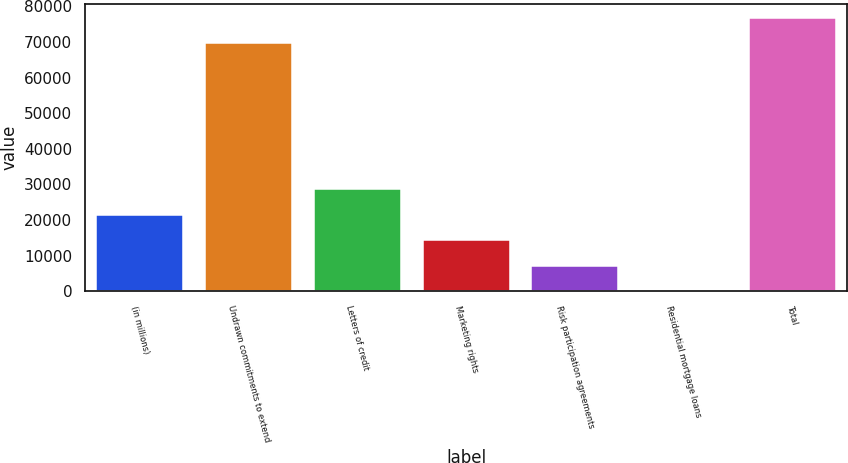<chart> <loc_0><loc_0><loc_500><loc_500><bar_chart><fcel>(in millions)<fcel>Undrawn commitments to extend<fcel>Letters of credit<fcel>Marketing rights<fcel>Risk participation agreements<fcel>Residential mortgage loans<fcel>Total<nl><fcel>21525.2<fcel>69553<fcel>28698.6<fcel>14351.8<fcel>7178.4<fcel>5<fcel>76726.4<nl></chart> 